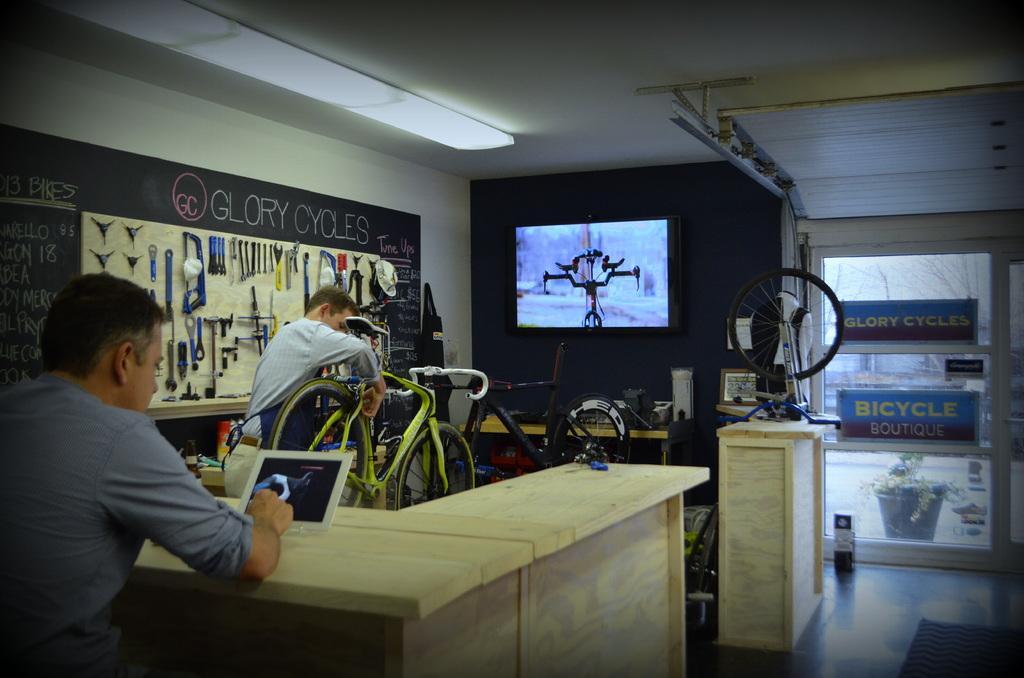How would you summarize this image in a sentence or two? This is an image clicked inside the room. On the left side there is a person sitting beside the table. In front of this person there is another man who is holding a bicycle in his hands. On the right side of the image there is a door. 